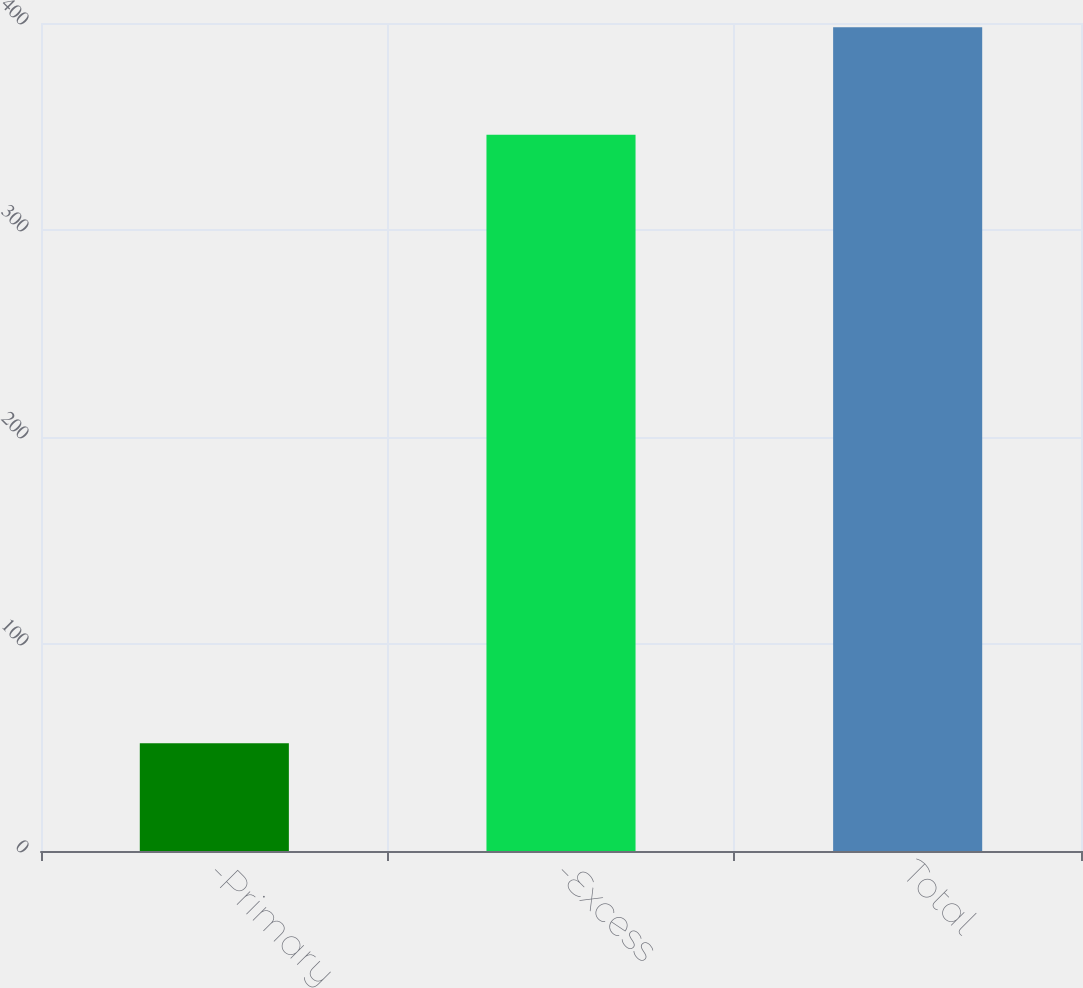Convert chart. <chart><loc_0><loc_0><loc_500><loc_500><bar_chart><fcel>-Primary<fcel>-Excess<fcel>Total<nl><fcel>52<fcel>346<fcel>398<nl></chart> 